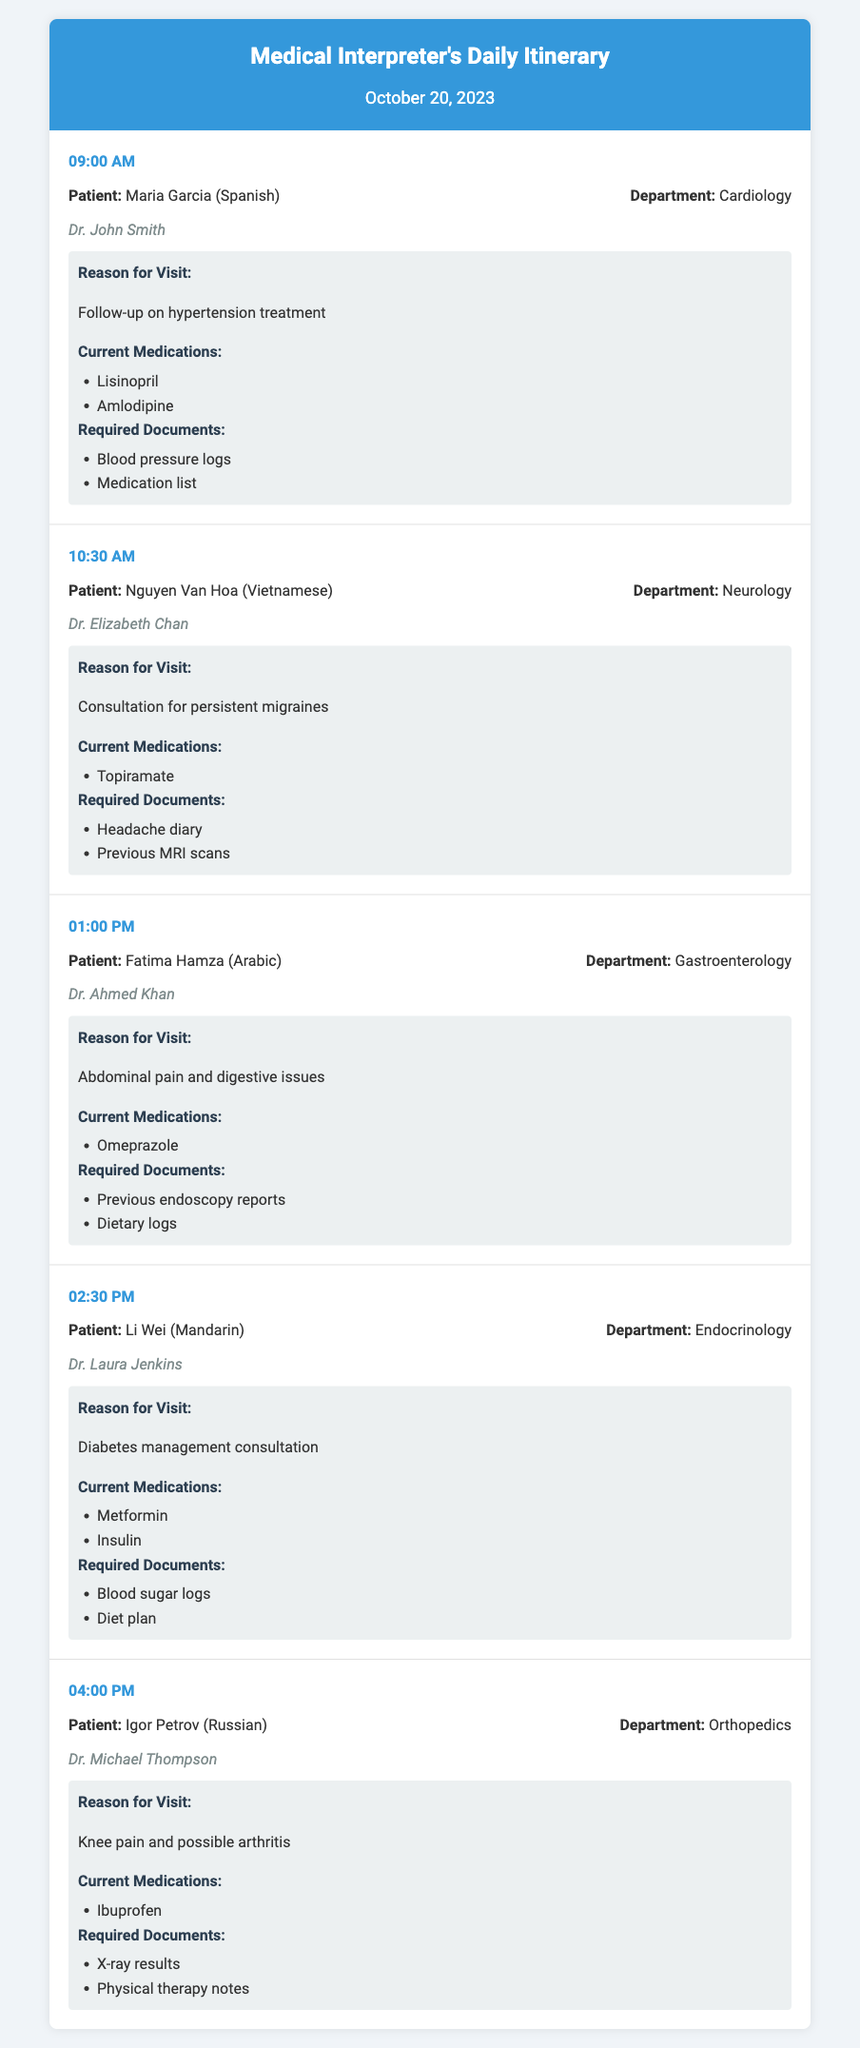What is the first patient's name? The first patient's name is listed at 09:00 AM in the appointment section.
Answer: Maria Garcia What time is the appointment for Fatima Hamza? Fatima Hamza's appointment is mentioned in the schedule under the specified time of 01:00 PM.
Answer: 01:00 PM Which doctor is seeing Nguyen Van Hoa? The doctor's name is specified in the appointment details for Nguyen Van Hoa at 10:30 AM.
Answer: Dr. Elizabeth Chan What reason does Li Wei have for the visit? The reason for Li Wei's visit is provided under the details section in the appointment scheduled for 02:30 PM.
Answer: Diabetes management consultation How many medications is Maria Garcia currently taking? The number of current medications for Maria Garcia is counted from the list in her appointment details.
Answer: 2 What is the required document for the appointment at 04:00 PM? The required documents for Igor Petrov's appointment are listed in the details section under his appointment scheduled for 04:00 PM.
Answer: X-ray results Which department is Fatima Hamza visiting? Fatima Hamza's department is mentioned in her appointment details at 01:00 PM.
Answer: Gastroenterology What language does Li Wei speak? Li Wei's language is indicated in the patient information section of his appointment.
Answer: Mandarin 